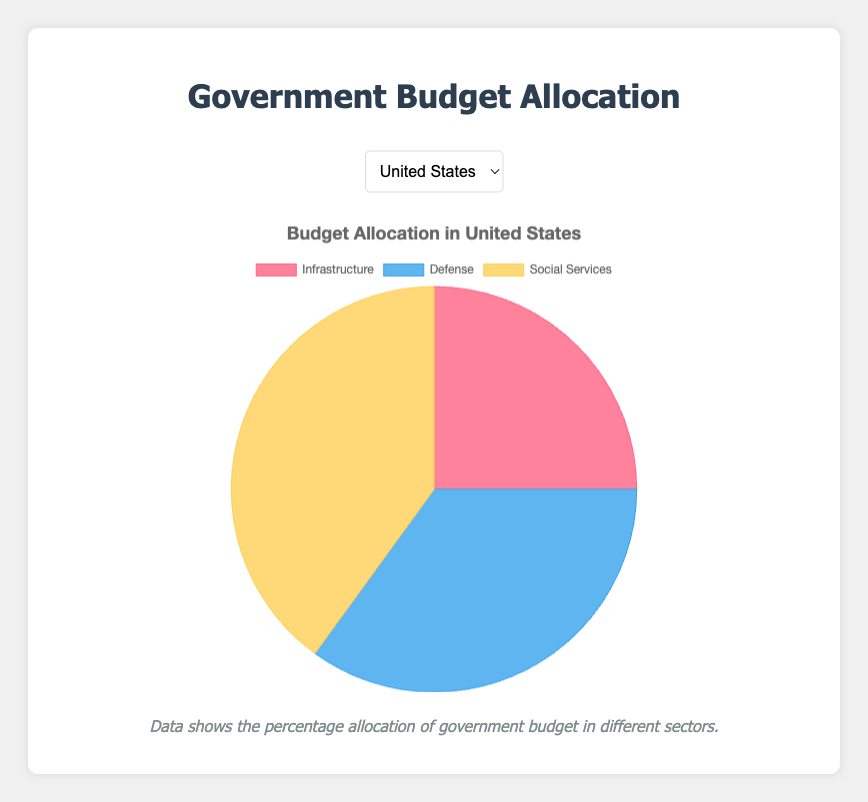What percentage of the United States' budget is allocated to social services? To determine the percentage of the United States’ budget allocated to social services, refer to the "social_services" value for the United States in the figure.
Answer: 40% How does Germany's defense budget allocation compare to its infrastructure budget allocation? Germany allocates 20% to defense and 30% to infrastructure. A simple comparison shows that infrastructure receives 10% more than defense.
Answer: Germany's infrastructure budget is 10% higher than its defense budget Considering both infrastructure and defense, what is the combined percentage allocation for Japan? Japan allocates 40% to infrastructure and 25% to defense. Adding these percentages together: 40 + 25 = 65.
Answer: 65% Which country allocates the largest percentage of its budget to social services? By examining the social services allocation for each country: United States (40%), Germany (50%), Sweden (65%), Japan (35%), and Canada (45%), it’s clear that Sweden allocates the most.
Answer: Sweden What is the difference between the budget allocation for social services in Canada and the United States? Canada allocates 45% to social services, while the United States allocates 40%. Subtracting these: 45 - 40 = 5.
Answer: 5% Between Sweden and Japan, which has a higher percentage allocated to defense? Sweden allocates 15% to defense, while Japan allocates 25%. A direct comparison shows Japan's percentage is higher.
Answer: Japan Which sector receives the largest budget allocation in Germany? Examining Germany's budget allocation: infrastructure (30%), defense (20%), and social services (50%), the largest allocation is for social services.
Answer: Social Services Is the percentage of the budget allocated to infrastructure greater, lesser, or equal to the percentage allocated to defense in Canada? In Canada, infrastructure receives 35% of the budget, and defense receives 20%. Infrastructure's percentage is greater than defense's.
Answer: Greater If you add the percentages allocated to infrastructure and social services in the United States, what is the resulting total? The United States allocates 25% to infrastructure and 40% to social services. Adding these: 25 + 40 = 65.
Answer: 65% Which country has the lowest allocation for defense, and what is the percentage? Comparing the defense allocations: United States (35%), Germany (20%), Sweden (15%), Japan (25%), and Canada (20%), Sweden has the lowest at 15%.
Answer: Sweden, 15% 